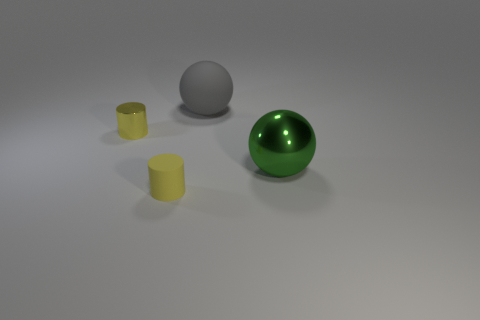There is a shiny cylinder; is its color the same as the matte object in front of the big gray rubber thing?
Your response must be concise. Yes. There is a thing that is behind the green metal object and to the right of the yellow rubber cylinder; what is its material?
Give a very brief answer. Rubber. There is another cylinder that is the same color as the matte cylinder; what is it made of?
Ensure brevity in your answer.  Metal. What is the color of the other thing that is the same shape as the big shiny thing?
Provide a succinct answer. Gray. Are there any tiny yellow rubber cylinders that are on the left side of the yellow cylinder behind the tiny cylinder that is in front of the small yellow metal object?
Ensure brevity in your answer.  No. Is the yellow rubber object the same shape as the tiny shiny thing?
Keep it short and to the point. Yes. Are there fewer big matte objects that are behind the big gray matte sphere than purple shiny blocks?
Your answer should be very brief. No. There is a tiny cylinder that is behind the large green metal ball that is on the right side of the small shiny object left of the big matte object; what is its color?
Ensure brevity in your answer.  Yellow. What number of metallic things are either yellow cylinders or large objects?
Keep it short and to the point. 2. Do the matte cylinder and the gray matte thing have the same size?
Provide a succinct answer. No. 